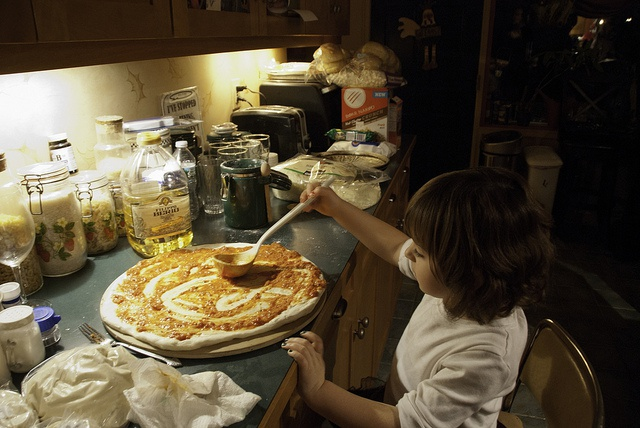Describe the objects in this image and their specific colors. I can see people in black, maroon, tan, and gray tones, pizza in black, olive, khaki, tan, and orange tones, chair in black, olive, and tan tones, bottle in black, tan, ivory, olive, and beige tones, and bottle in black, olive, and ivory tones in this image. 